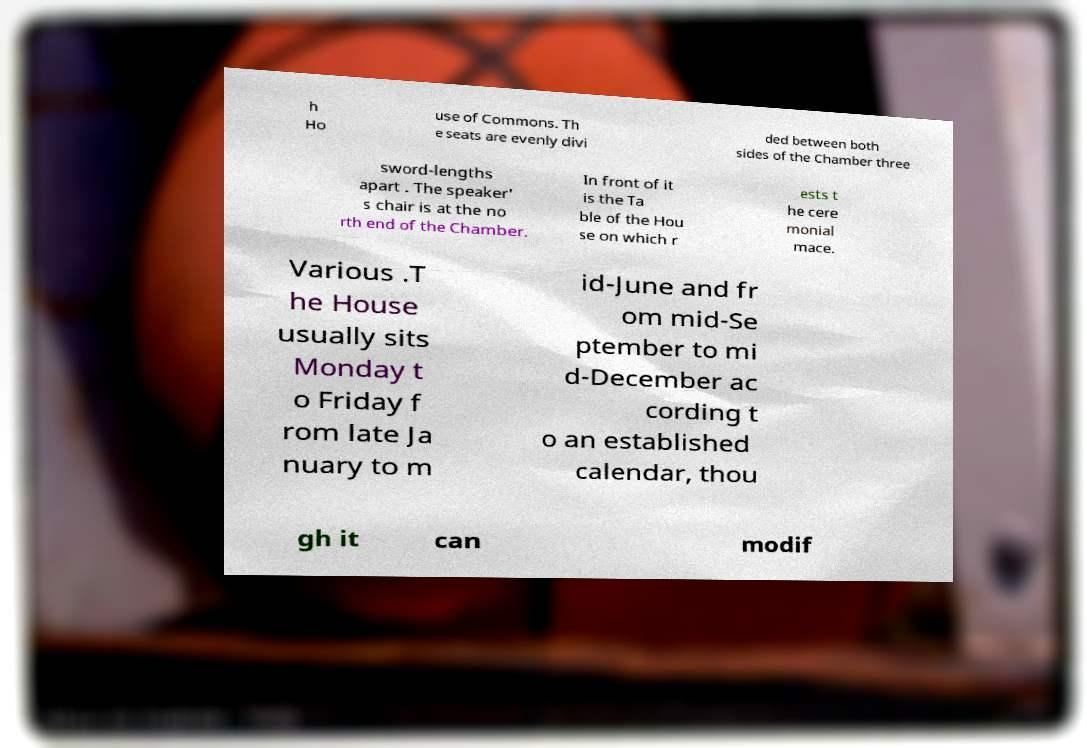Can you read and provide the text displayed in the image?This photo seems to have some interesting text. Can you extract and type it out for me? h Ho use of Commons. Th e seats are evenly divi ded between both sides of the Chamber three sword-lengths apart . The speaker' s chair is at the no rth end of the Chamber. In front of it is the Ta ble of the Hou se on which r ests t he cere monial mace. Various .T he House usually sits Monday t o Friday f rom late Ja nuary to m id-June and fr om mid-Se ptember to mi d-December ac cording t o an established calendar, thou gh it can modif 